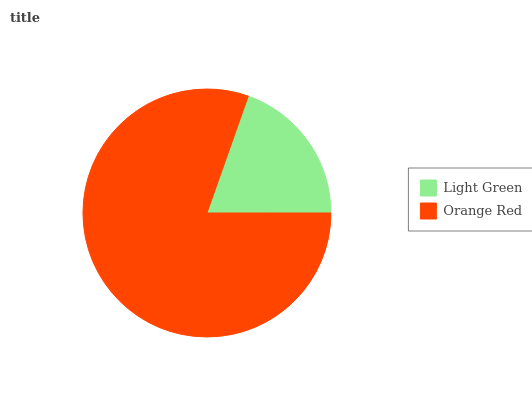Is Light Green the minimum?
Answer yes or no. Yes. Is Orange Red the maximum?
Answer yes or no. Yes. Is Orange Red the minimum?
Answer yes or no. No. Is Orange Red greater than Light Green?
Answer yes or no. Yes. Is Light Green less than Orange Red?
Answer yes or no. Yes. Is Light Green greater than Orange Red?
Answer yes or no. No. Is Orange Red less than Light Green?
Answer yes or no. No. Is Orange Red the high median?
Answer yes or no. Yes. Is Light Green the low median?
Answer yes or no. Yes. Is Light Green the high median?
Answer yes or no. No. Is Orange Red the low median?
Answer yes or no. No. 